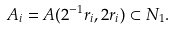<formula> <loc_0><loc_0><loc_500><loc_500>A _ { i } = A ( 2 ^ { - 1 } r _ { i } , 2 r _ { i } ) \subset N _ { 1 } .</formula> 